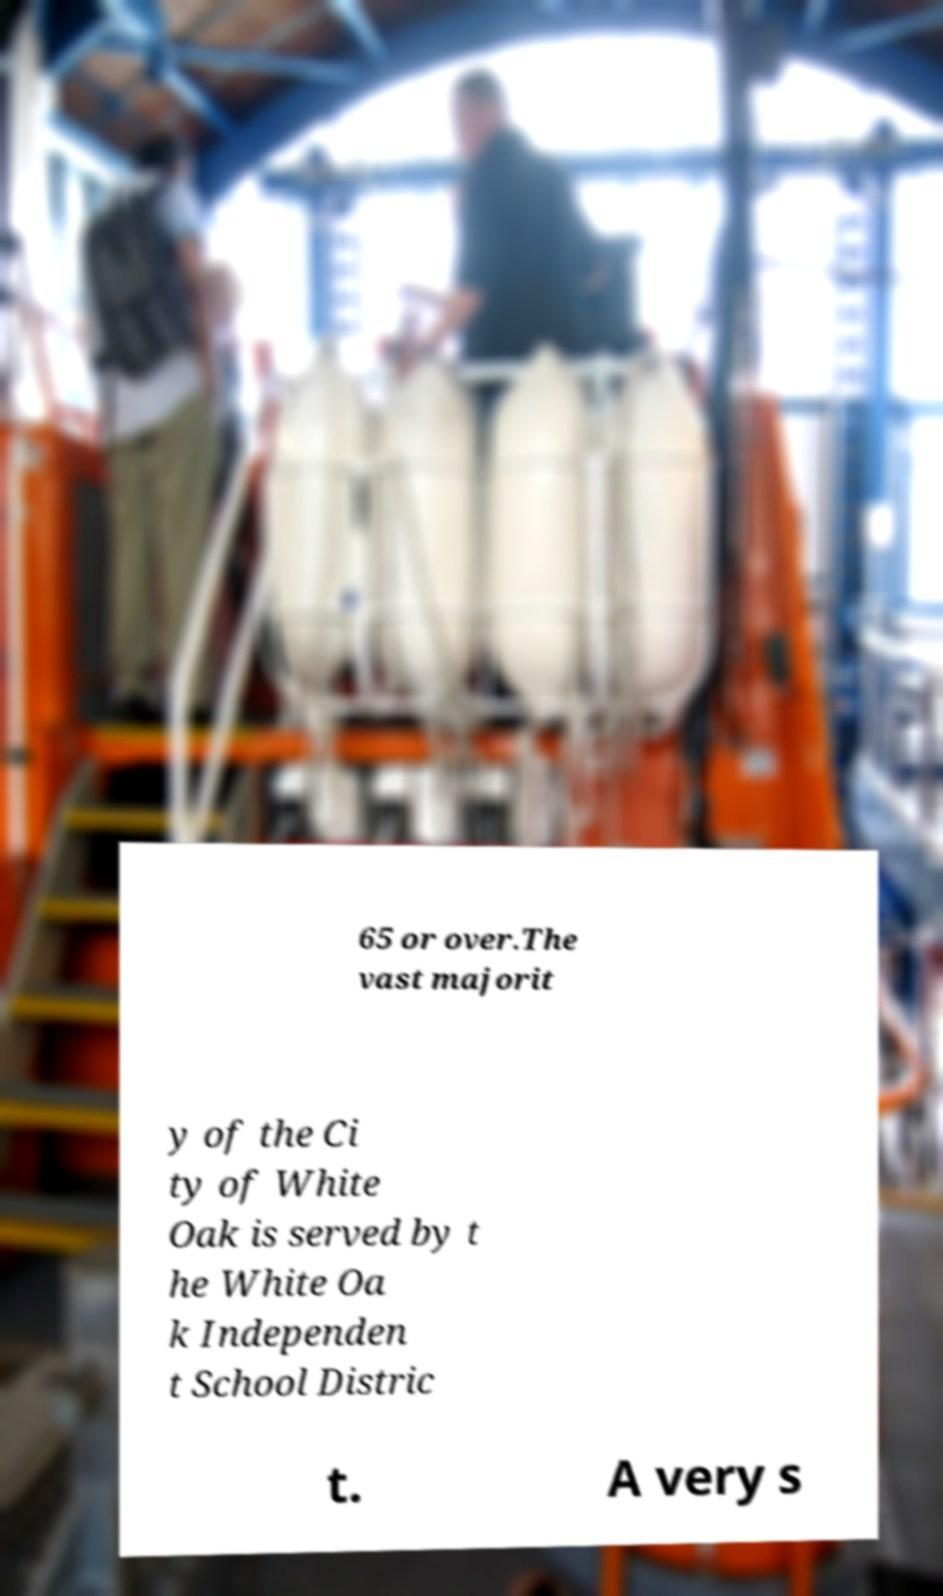Please identify and transcribe the text found in this image. 65 or over.The vast majorit y of the Ci ty of White Oak is served by t he White Oa k Independen t School Distric t. A very s 